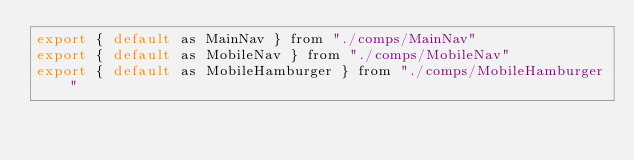Convert code to text. <code><loc_0><loc_0><loc_500><loc_500><_JavaScript_>export { default as MainNav } from "./comps/MainNav"
export { default as MobileNav } from "./comps/MobileNav"
export { default as MobileHamburger } from "./comps/MobileHamburger"
</code> 